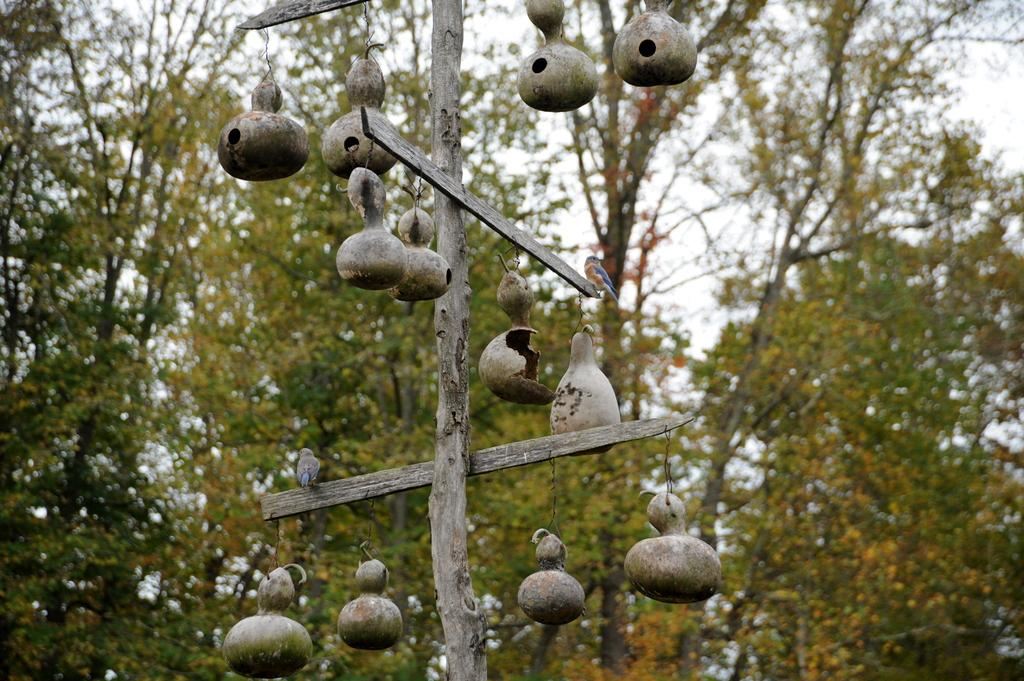What animals can be seen in the image? There are two birds standing in the image. What structures are associated with the birds in the image? There are nests hanging from a stick in the image. What type of natural environment is depicted in the image? There are trees with branches and leaves in the image. What force is being applied to the circle in the image? There is no circle present in the image, so it is not possible to determine if any force is being applied to it. 